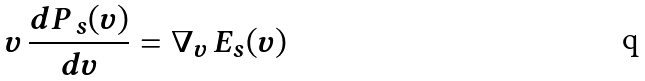Convert formula to latex. <formula><loc_0><loc_0><loc_500><loc_500>v \, \frac { { d } P _ { \, s } ( v ) } { { d } v } = \nabla _ { v } \, E _ { s } ( v )</formula> 